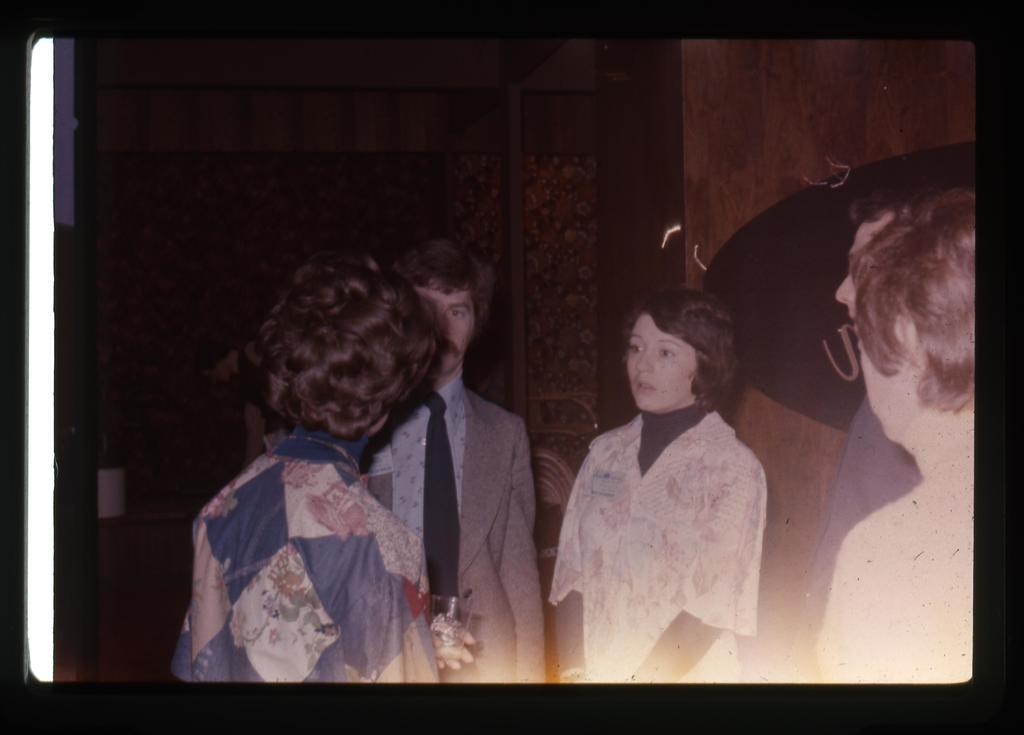How many people are in the image? There are persons visible in the image. What is one person holding in the image? One person is holding a glass. What song is being sung by the person holding the glass in the image? There is no indication in the image that a song is being sung, so it cannot be determined from the picture. 